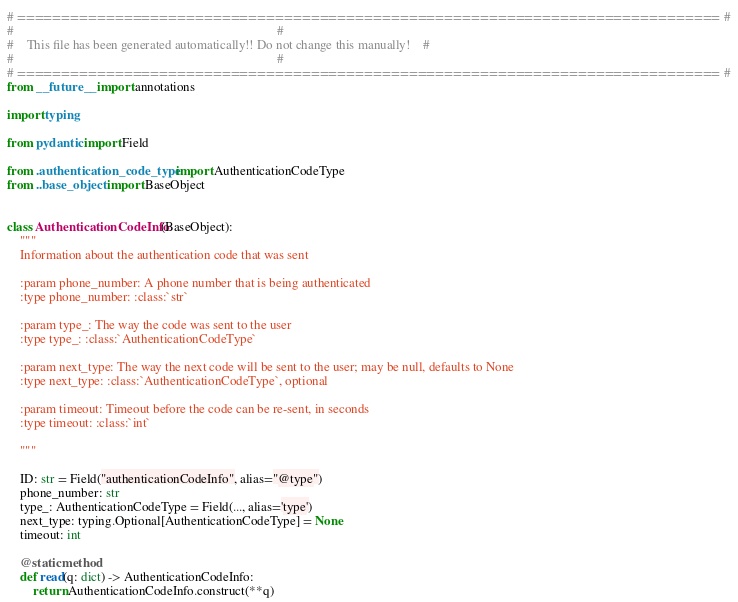Convert code to text. <code><loc_0><loc_0><loc_500><loc_500><_Python_># =============================================================================== #
#                                                                                 #
#    This file has been generated automatically!! Do not change this manually!    #
#                                                                                 #
# =============================================================================== #
from __future__ import annotations

import typing

from pydantic import Field

from .authentication_code_type import AuthenticationCodeType
from ..base_object import BaseObject


class AuthenticationCodeInfo(BaseObject):
    """
    Information about the authentication code that was sent
    
    :param phone_number: A phone number that is being authenticated
    :type phone_number: :class:`str`
    
    :param type_: The way the code was sent to the user
    :type type_: :class:`AuthenticationCodeType`
    
    :param next_type: The way the next code will be sent to the user; may be null, defaults to None
    :type next_type: :class:`AuthenticationCodeType`, optional
    
    :param timeout: Timeout before the code can be re-sent, in seconds
    :type timeout: :class:`int`
    
    """

    ID: str = Field("authenticationCodeInfo", alias="@type")
    phone_number: str
    type_: AuthenticationCodeType = Field(..., alias='type')
    next_type: typing.Optional[AuthenticationCodeType] = None
    timeout: int

    @staticmethod
    def read(q: dict) -> AuthenticationCodeInfo:
        return AuthenticationCodeInfo.construct(**q)
</code> 